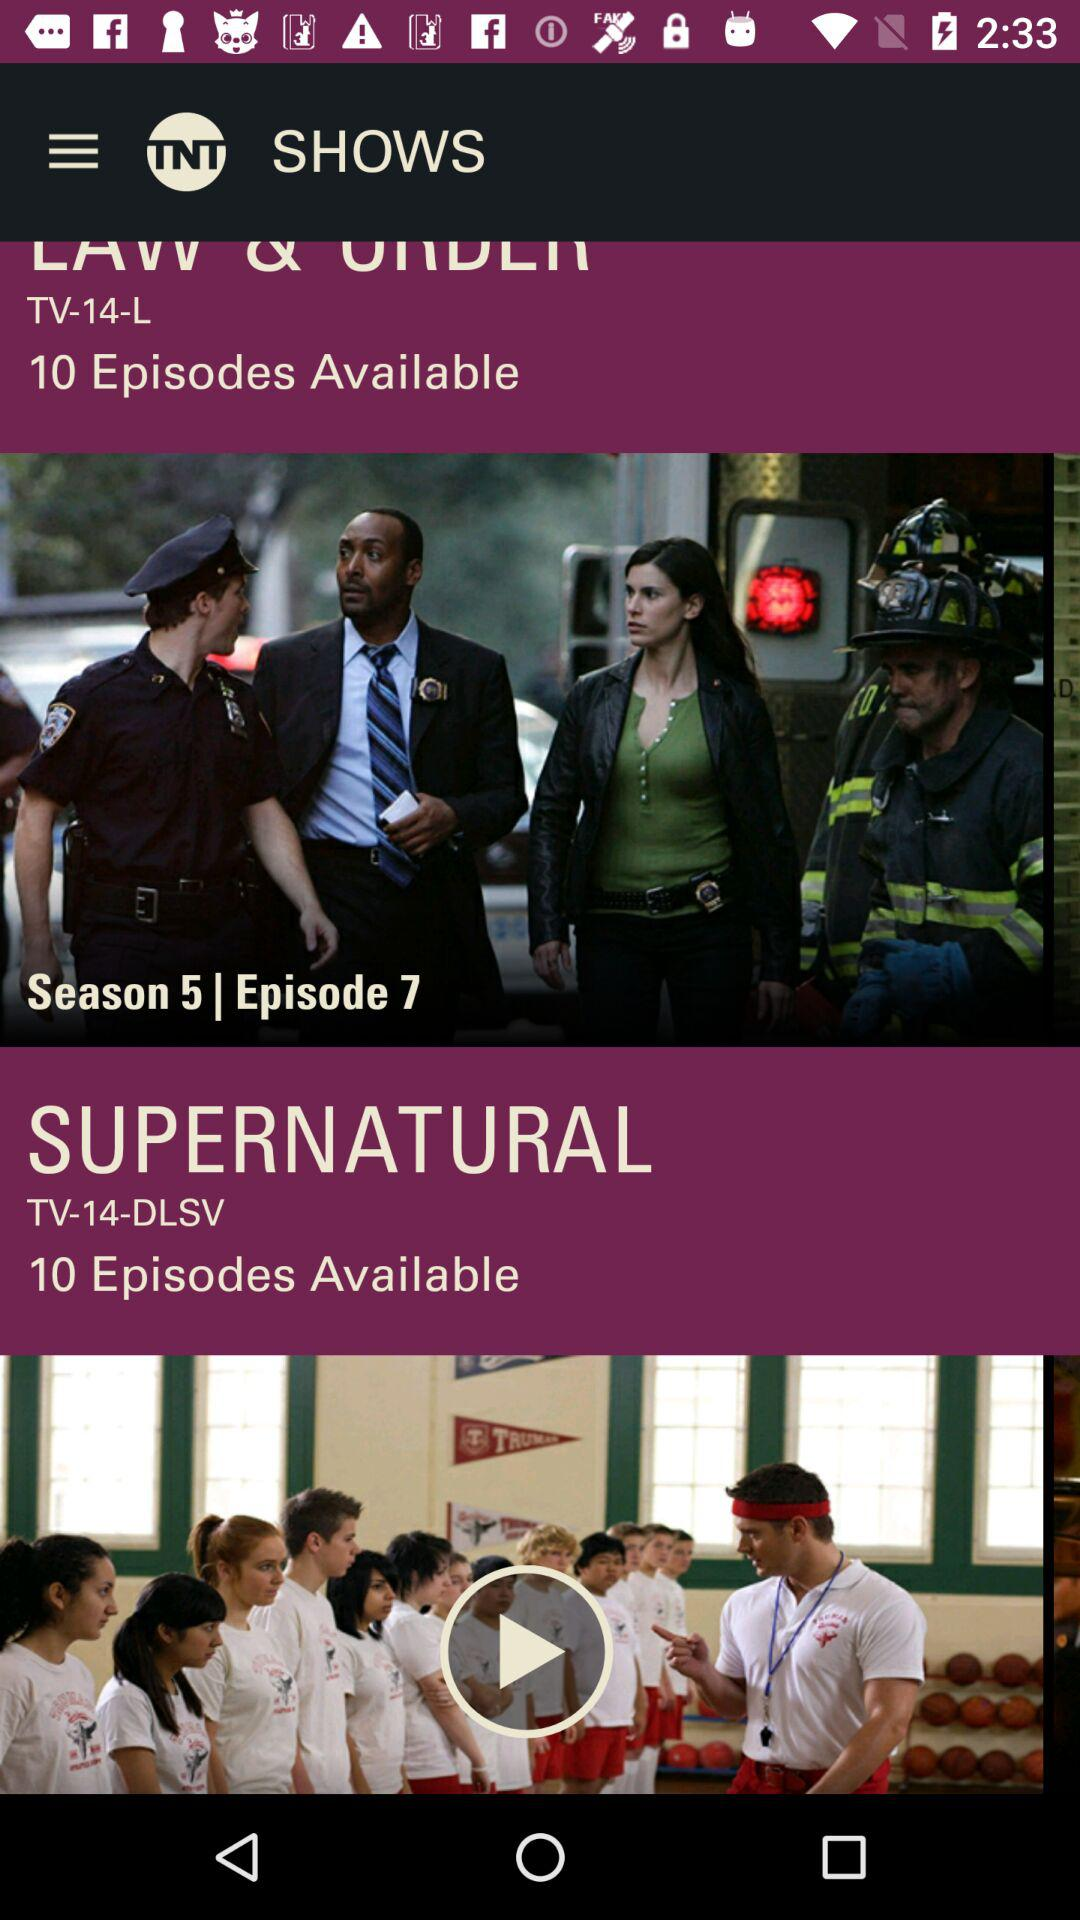What's the series name? The series name is Supernatural. 